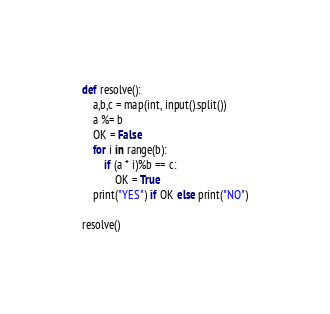Convert code to text. <code><loc_0><loc_0><loc_500><loc_500><_Python_>def resolve():
    a,b,c = map(int, input().split())
    a %= b
    OK = False
    for i in range(b):
        if (a * i)%b == c:
            OK = True
    print("YES") if OK else print("NO")

resolve()</code> 